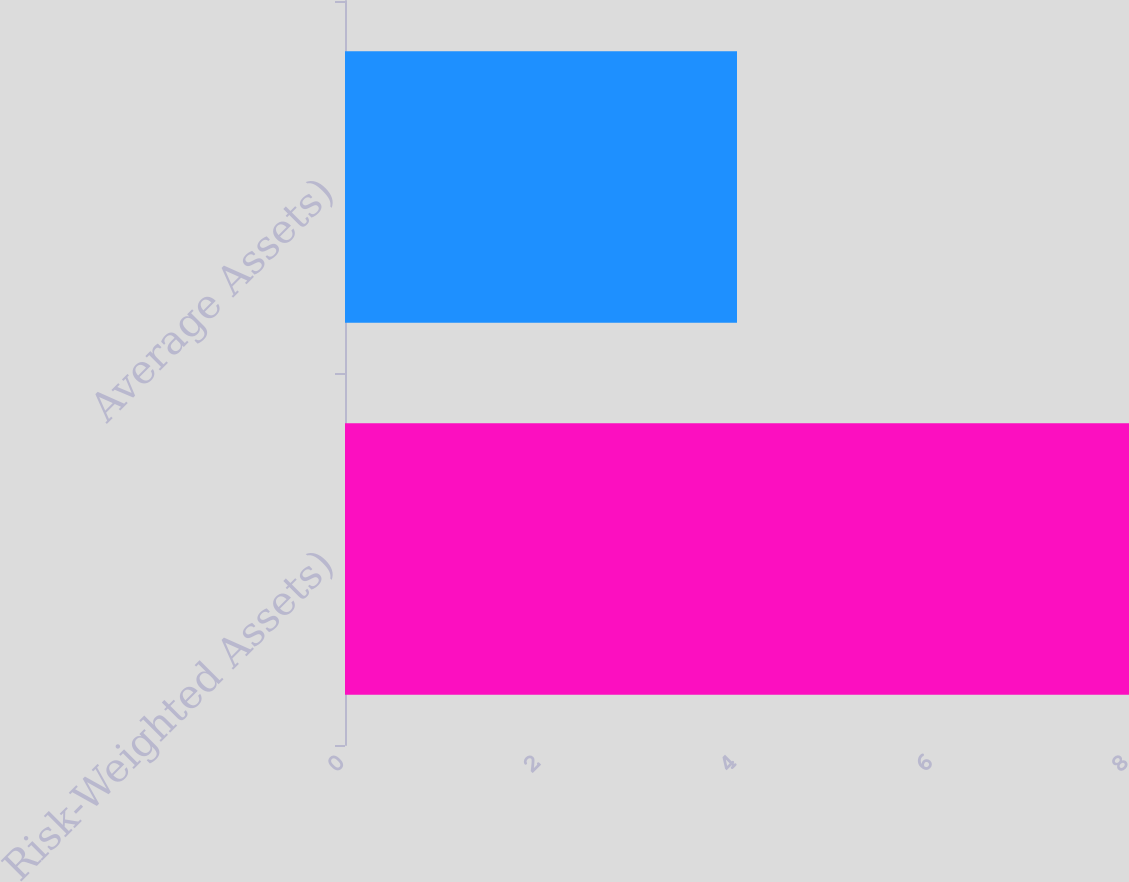Convert chart to OTSL. <chart><loc_0><loc_0><loc_500><loc_500><bar_chart><fcel>Risk-Weighted Assets)<fcel>Average Assets)<nl><fcel>8<fcel>4<nl></chart> 